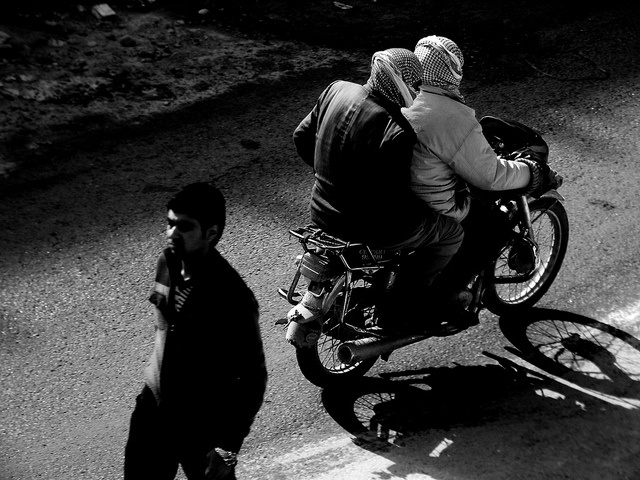Describe the objects in this image and their specific colors. I can see people in black, gray, darkgray, and lightgray tones, motorcycle in black, darkgray, gray, and lightgray tones, people in black, gray, darkgray, and lightgray tones, and people in black, gray, darkgray, and lightgray tones in this image. 